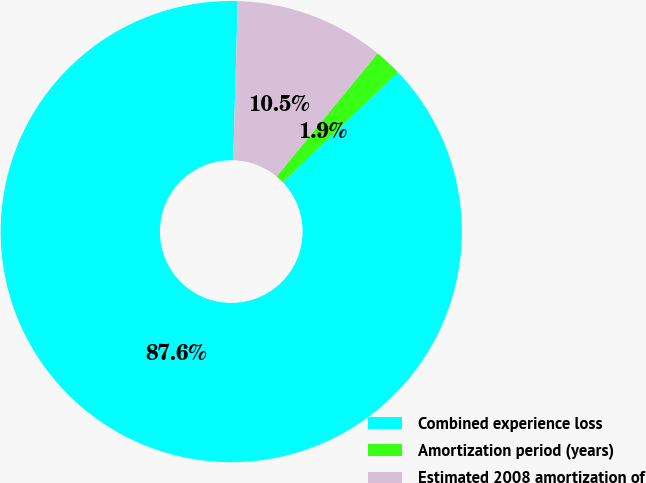Convert chart to OTSL. <chart><loc_0><loc_0><loc_500><loc_500><pie_chart><fcel>Combined experience loss<fcel>Amortization period (years)<fcel>Estimated 2008 amortization of<nl><fcel>87.59%<fcel>1.92%<fcel>10.49%<nl></chart> 